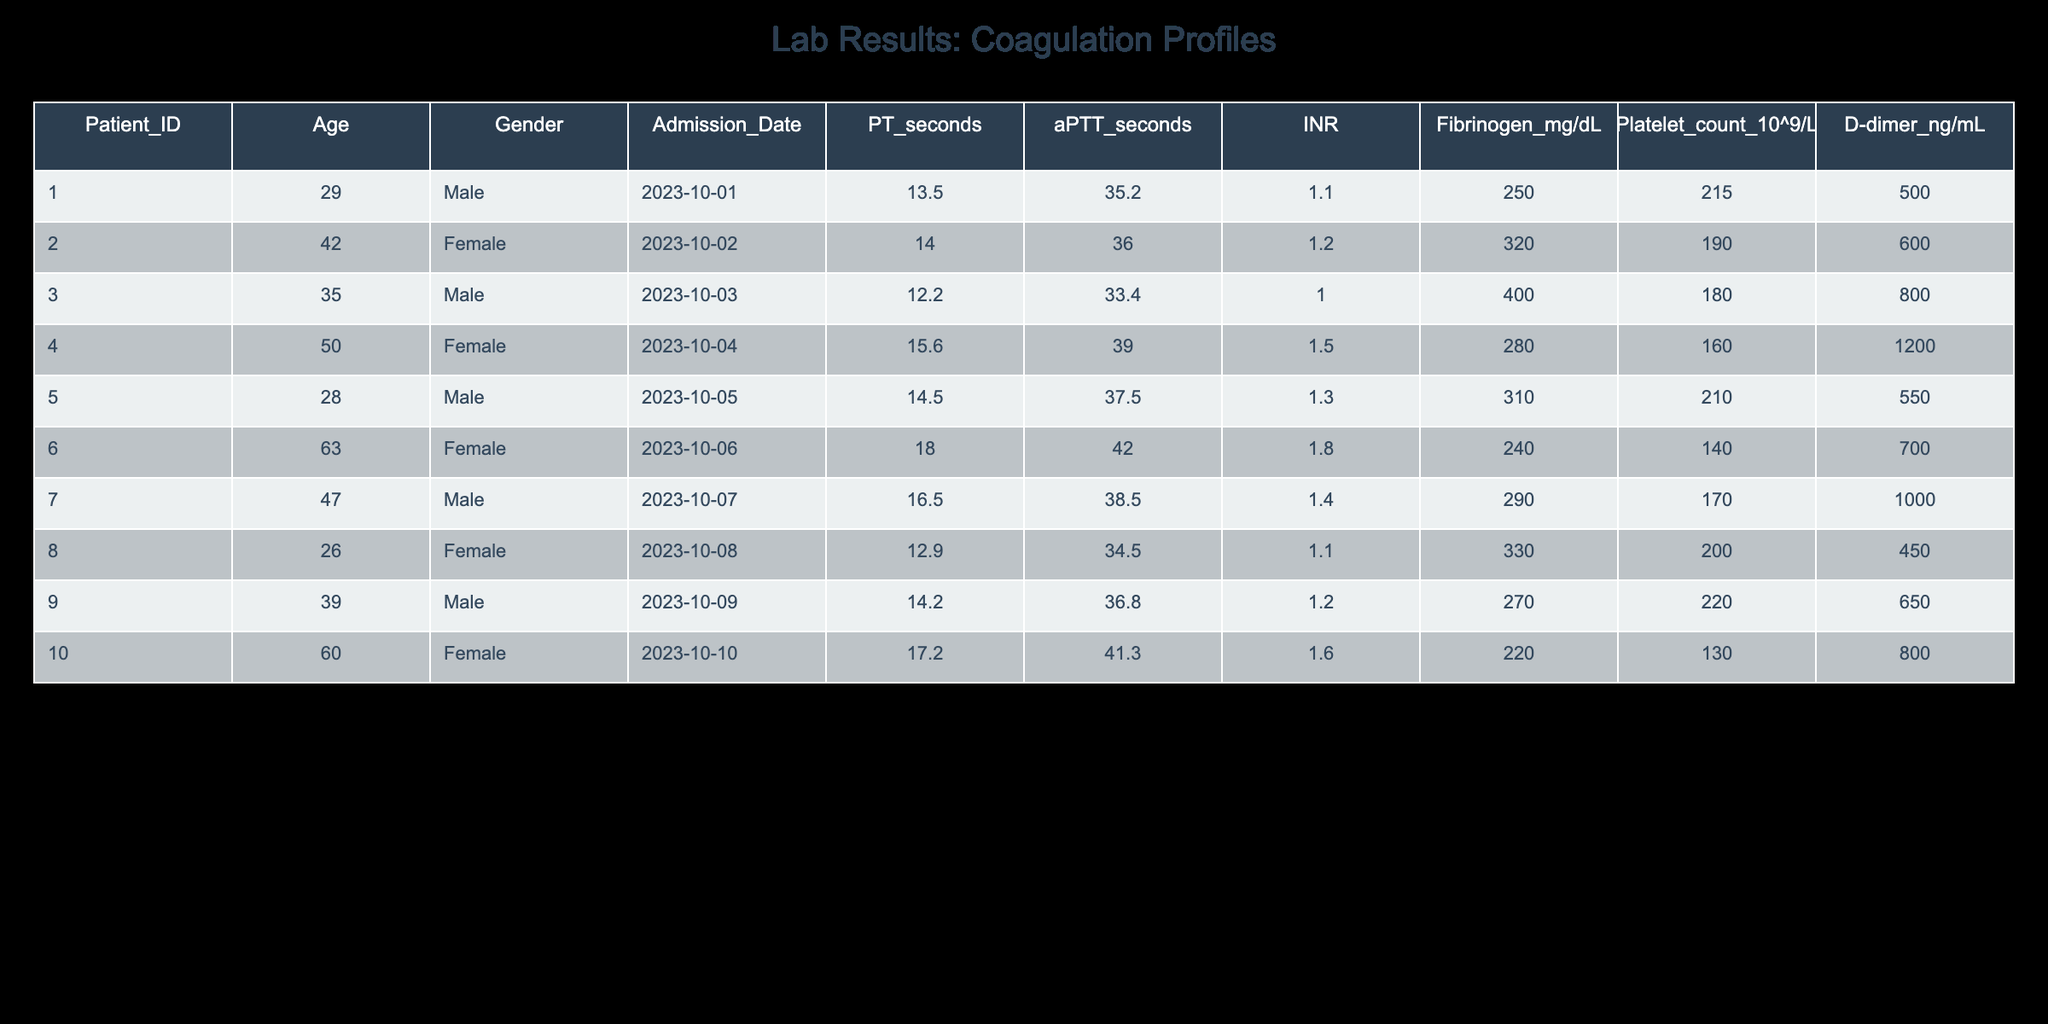What is the D-dimer level for Patient ID 007? The table indicates that the D-dimer level for Patient ID 007 is listed in the D-dimer column, which shows a value of 1000 ng/mL.
Answer: 1000 ng/mL What is the age of the oldest patient? To find the oldest patient, I look at the Age column and identify the maximum value, which is 63 for Patient ID 006.
Answer: 63 Is the Fibrinogen level for Patient ID 004 greater than 300 mg/dL? Patient ID 004 has a Fibrinogen level of 280 mg/dL, which is less than 300 mg/dL. Thus, the statement is false.
Answer: No What is the average aPTT (activated Partial Thromboplastin Time) in seconds for all patients? To calculate the average aPTT, I add all the values from the aPTT column (35.2 + 36.0 + 33.4 + 39.0 + 37.5 + 42.0 + 38.5 + 34.5 + 36.8 + 41.3 =  393.9) and divide by the total number of patients (10). The average is 393.9 / 10 = 39.39 seconds.
Answer: 39.39 seconds Which patient has the lowest PT (Prothrombin Time) in seconds? By examining the PT seconds column, I see that Patient ID 003 has the lowest PT time at 12.2 seconds.
Answer: Patient ID 003 What is the difference between the highest and lowest platelet count among the patients? The highest platelet count is 220 for Patient ID 009, and the lowest is 130 for Patient ID 010. The difference is calculated as 220 - 130 = 90.
Answer: 90 Are there any female patients with an INR greater than 1.5? By reviewing the INR values for female patients (001, 002, 004, 006, 010), I find that only Patient ID 004 has an INR of 1.5, which is not greater than 1.5; therefore, no female patient meets the criteria.
Answer: No What percentage of patients have a Fibrinogen level lower than 300 mg/dL? There are 10 patients total; among them, Patient IDs 001, 004, and 010 have Fibrinogen levels lower than 300 mg/dL (250, 280, and 220, respectively). This is 3 out of 10, resulting in a percentage of (3/10) * 100 = 30%.
Answer: 30% 